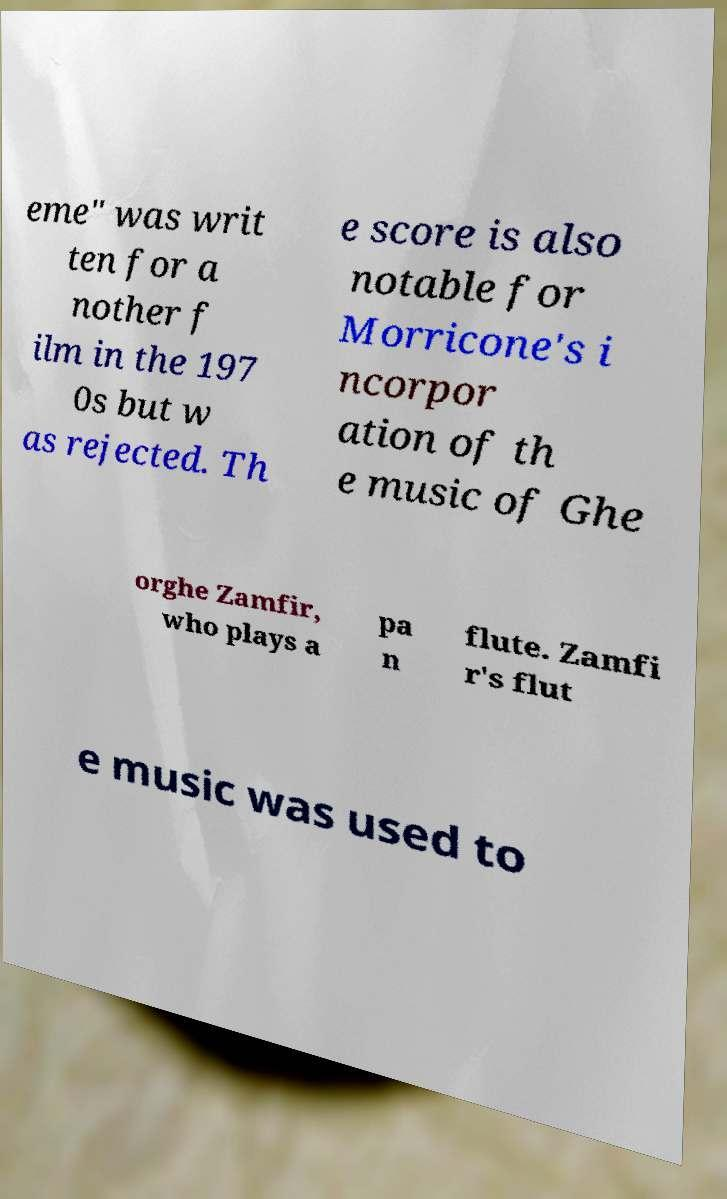Can you accurately transcribe the text from the provided image for me? eme" was writ ten for a nother f ilm in the 197 0s but w as rejected. Th e score is also notable for Morricone's i ncorpor ation of th e music of Ghe orghe Zamfir, who plays a pa n flute. Zamfi r's flut e music was used to 